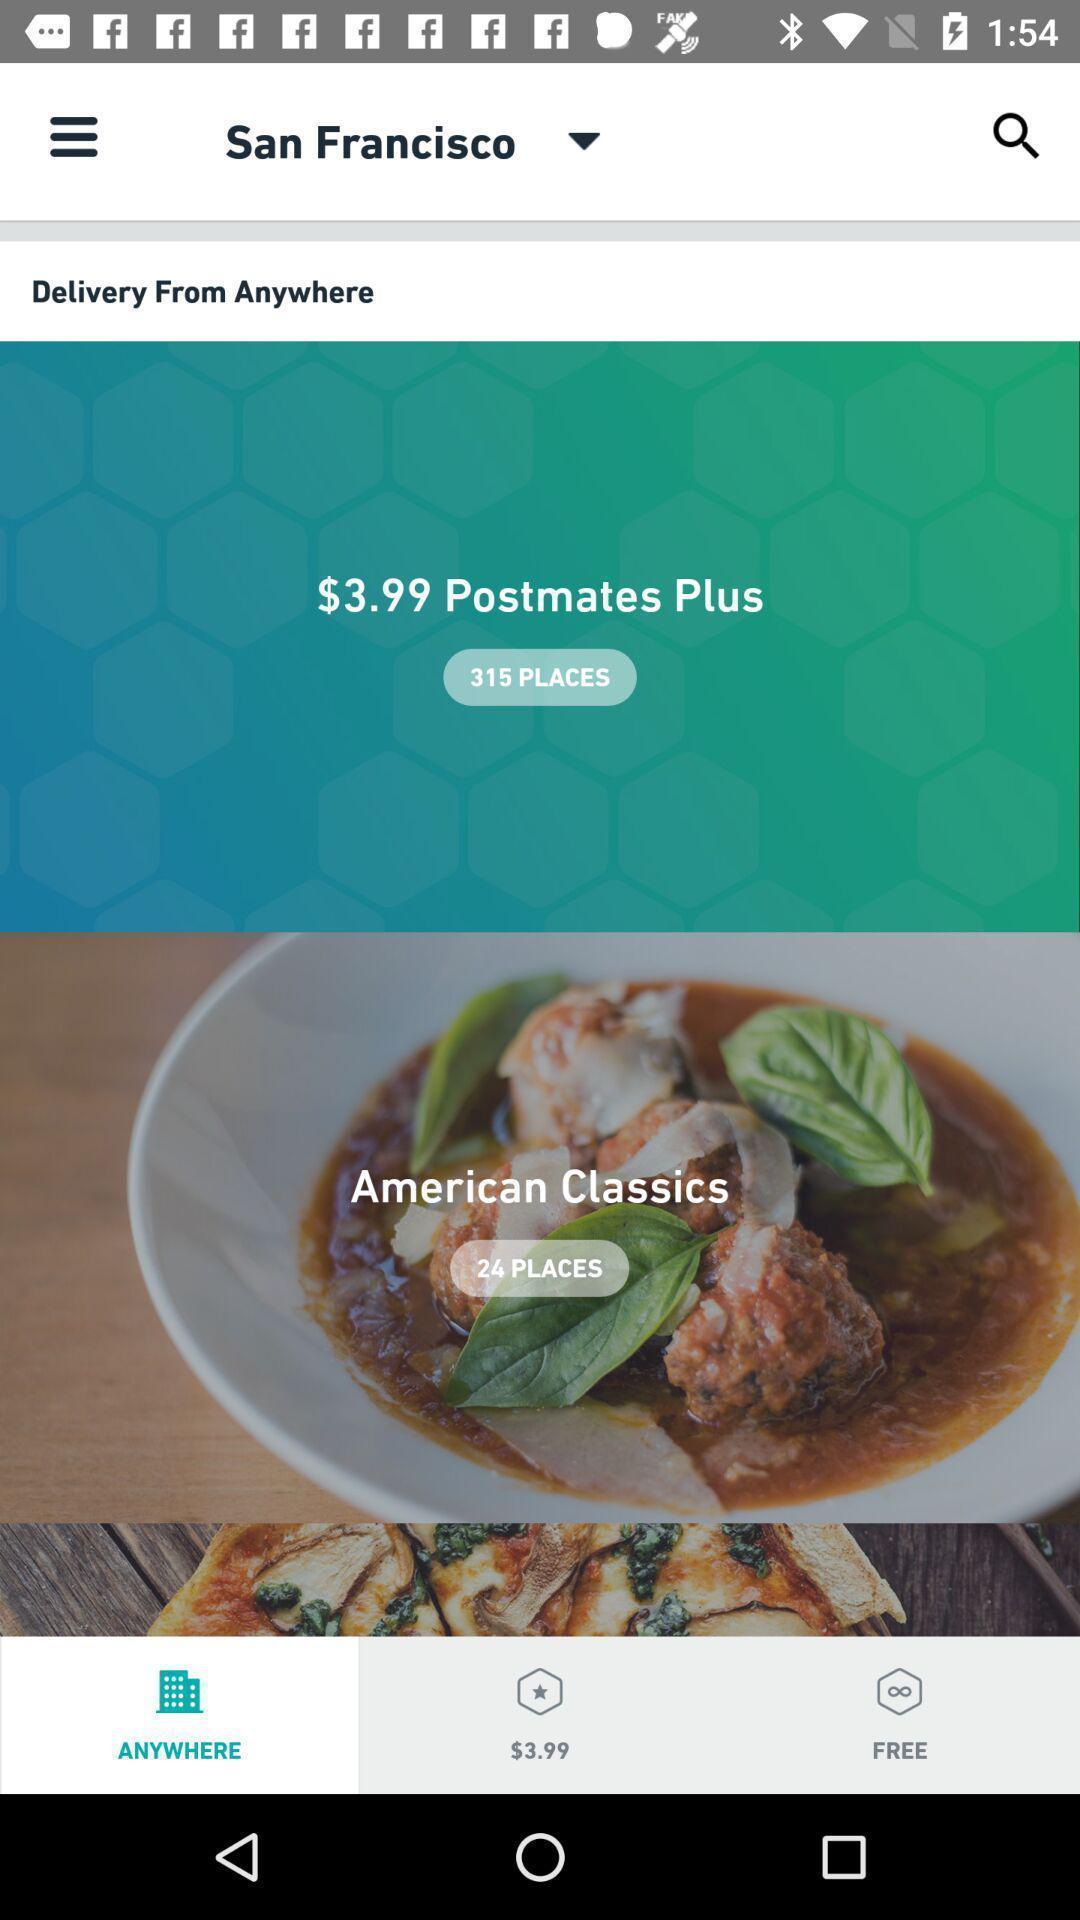Describe this image in words. Screen asking to deliver from any where. 